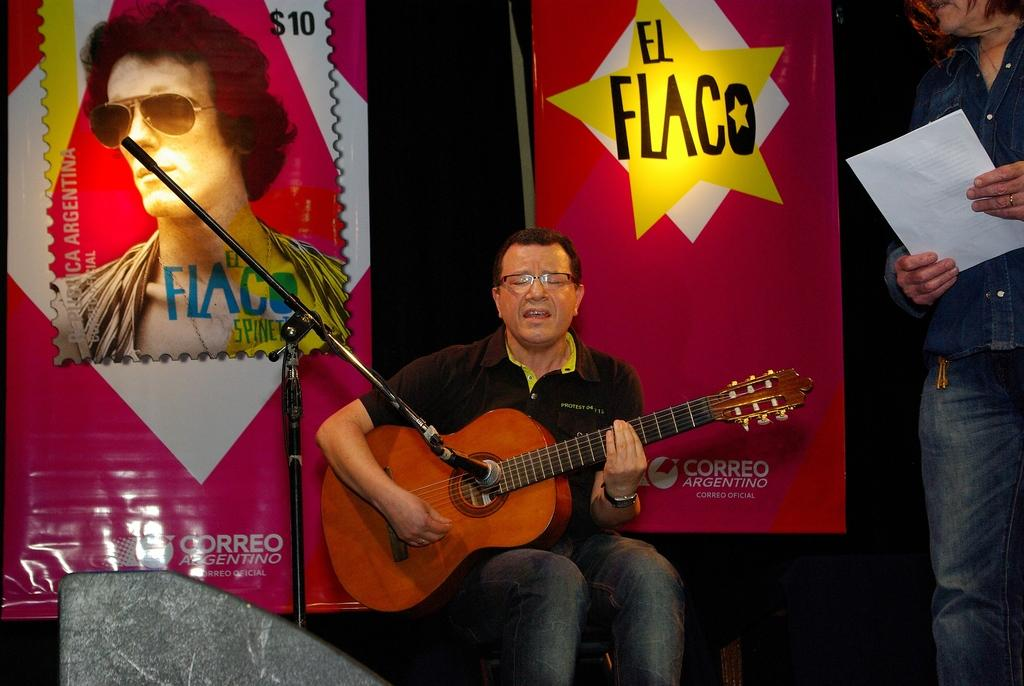What is the person on the left side of the image holding? The person on the left side of the image is holding a guitar. What is the person on the right side of the image holding? The person on the right side of the image is holding a paper. What can be seen in the background of the image? There are banners in the background of the image. What type of mine is visible in the image? There is no mine present in the image. 